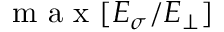<formula> <loc_0><loc_0><loc_500><loc_500>m a x [ E _ { \sigma } / E _ { \perp } ]</formula> 